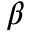<formula> <loc_0><loc_0><loc_500><loc_500>\beta</formula> 